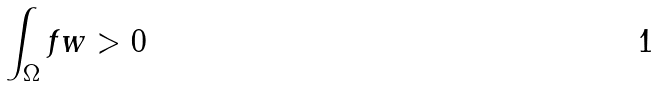Convert formula to latex. <formula><loc_0><loc_0><loc_500><loc_500>\int _ { \Omega } f w > 0</formula> 